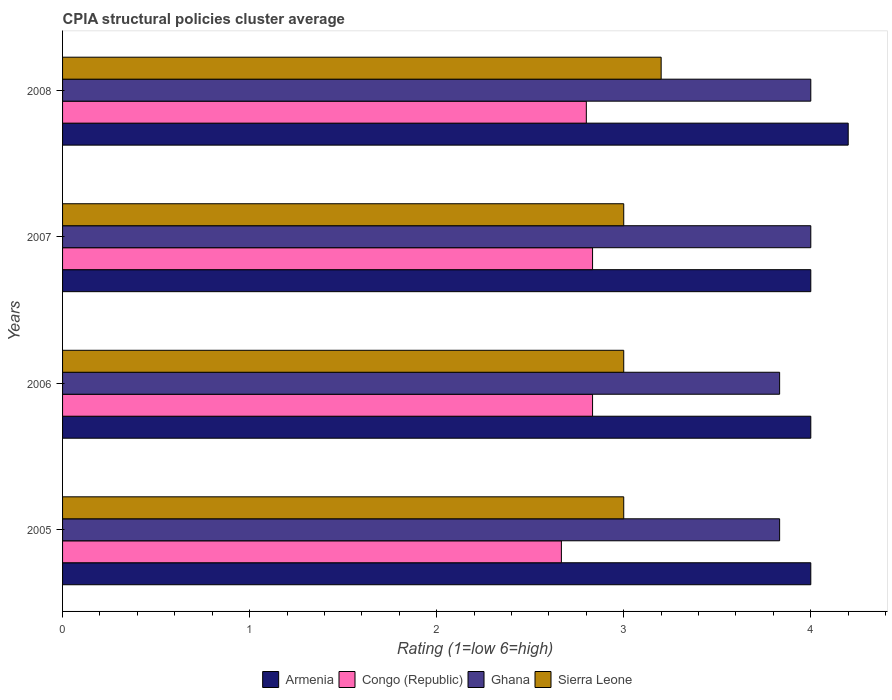How many different coloured bars are there?
Offer a very short reply. 4. How many groups of bars are there?
Offer a terse response. 4. What is the label of the 1st group of bars from the top?
Give a very brief answer. 2008. In how many cases, is the number of bars for a given year not equal to the number of legend labels?
Your response must be concise. 0. What is the CPIA rating in Ghana in 2006?
Provide a short and direct response. 3.83. Across all years, what is the maximum CPIA rating in Congo (Republic)?
Your response must be concise. 2.83. What is the difference between the CPIA rating in Congo (Republic) in 2006 and the CPIA rating in Armenia in 2005?
Ensure brevity in your answer.  -1.17. What is the average CPIA rating in Armenia per year?
Your response must be concise. 4.05. In the year 2005, what is the difference between the CPIA rating in Congo (Republic) and CPIA rating in Sierra Leone?
Offer a very short reply. -0.33. Is the CPIA rating in Armenia in 2006 less than that in 2008?
Make the answer very short. Yes. What is the difference between the highest and the second highest CPIA rating in Sierra Leone?
Offer a very short reply. 0.2. What is the difference between the highest and the lowest CPIA rating in Ghana?
Provide a short and direct response. 0.17. In how many years, is the CPIA rating in Ghana greater than the average CPIA rating in Ghana taken over all years?
Your response must be concise. 2. What does the 1st bar from the top in 2006 represents?
Your answer should be very brief. Sierra Leone. Is it the case that in every year, the sum of the CPIA rating in Armenia and CPIA rating in Ghana is greater than the CPIA rating in Sierra Leone?
Provide a succinct answer. Yes. How many years are there in the graph?
Keep it short and to the point. 4. Are the values on the major ticks of X-axis written in scientific E-notation?
Your response must be concise. No. Does the graph contain any zero values?
Offer a terse response. No. Does the graph contain grids?
Make the answer very short. No. How many legend labels are there?
Give a very brief answer. 4. What is the title of the graph?
Provide a short and direct response. CPIA structural policies cluster average. What is the label or title of the X-axis?
Make the answer very short. Rating (1=low 6=high). What is the Rating (1=low 6=high) of Armenia in 2005?
Keep it short and to the point. 4. What is the Rating (1=low 6=high) in Congo (Republic) in 2005?
Offer a very short reply. 2.67. What is the Rating (1=low 6=high) in Ghana in 2005?
Offer a terse response. 3.83. What is the Rating (1=low 6=high) of Sierra Leone in 2005?
Make the answer very short. 3. What is the Rating (1=low 6=high) of Congo (Republic) in 2006?
Your answer should be compact. 2.83. What is the Rating (1=low 6=high) in Ghana in 2006?
Offer a very short reply. 3.83. What is the Rating (1=low 6=high) in Armenia in 2007?
Keep it short and to the point. 4. What is the Rating (1=low 6=high) of Congo (Republic) in 2007?
Your response must be concise. 2.83. What is the Rating (1=low 6=high) of Congo (Republic) in 2008?
Keep it short and to the point. 2.8. What is the Rating (1=low 6=high) in Sierra Leone in 2008?
Your answer should be compact. 3.2. Across all years, what is the maximum Rating (1=low 6=high) of Congo (Republic)?
Provide a short and direct response. 2.83. Across all years, what is the minimum Rating (1=low 6=high) in Armenia?
Your response must be concise. 4. Across all years, what is the minimum Rating (1=low 6=high) in Congo (Republic)?
Offer a very short reply. 2.67. Across all years, what is the minimum Rating (1=low 6=high) in Ghana?
Make the answer very short. 3.83. What is the total Rating (1=low 6=high) of Armenia in the graph?
Give a very brief answer. 16.2. What is the total Rating (1=low 6=high) of Congo (Republic) in the graph?
Give a very brief answer. 11.13. What is the total Rating (1=low 6=high) of Ghana in the graph?
Offer a terse response. 15.67. What is the total Rating (1=low 6=high) of Sierra Leone in the graph?
Provide a succinct answer. 12.2. What is the difference between the Rating (1=low 6=high) in Congo (Republic) in 2005 and that in 2006?
Provide a short and direct response. -0.17. What is the difference between the Rating (1=low 6=high) of Ghana in 2005 and that in 2006?
Provide a short and direct response. 0. What is the difference between the Rating (1=low 6=high) in Sierra Leone in 2005 and that in 2007?
Give a very brief answer. 0. What is the difference between the Rating (1=low 6=high) of Armenia in 2005 and that in 2008?
Give a very brief answer. -0.2. What is the difference between the Rating (1=low 6=high) of Congo (Republic) in 2005 and that in 2008?
Your response must be concise. -0.13. What is the difference between the Rating (1=low 6=high) in Ghana in 2005 and that in 2008?
Provide a short and direct response. -0.17. What is the difference between the Rating (1=low 6=high) in Sierra Leone in 2005 and that in 2008?
Provide a succinct answer. -0.2. What is the difference between the Rating (1=low 6=high) in Congo (Republic) in 2006 and that in 2007?
Provide a succinct answer. 0. What is the difference between the Rating (1=low 6=high) in Armenia in 2006 and that in 2008?
Offer a terse response. -0.2. What is the difference between the Rating (1=low 6=high) in Congo (Republic) in 2007 and that in 2008?
Your answer should be compact. 0.03. What is the difference between the Rating (1=low 6=high) of Armenia in 2005 and the Rating (1=low 6=high) of Congo (Republic) in 2006?
Keep it short and to the point. 1.17. What is the difference between the Rating (1=low 6=high) in Armenia in 2005 and the Rating (1=low 6=high) in Ghana in 2006?
Offer a very short reply. 0.17. What is the difference between the Rating (1=low 6=high) of Congo (Republic) in 2005 and the Rating (1=low 6=high) of Ghana in 2006?
Offer a terse response. -1.17. What is the difference between the Rating (1=low 6=high) in Armenia in 2005 and the Rating (1=low 6=high) in Ghana in 2007?
Offer a terse response. 0. What is the difference between the Rating (1=low 6=high) in Armenia in 2005 and the Rating (1=low 6=high) in Sierra Leone in 2007?
Give a very brief answer. 1. What is the difference between the Rating (1=low 6=high) in Congo (Republic) in 2005 and the Rating (1=low 6=high) in Ghana in 2007?
Your response must be concise. -1.33. What is the difference between the Rating (1=low 6=high) in Congo (Republic) in 2005 and the Rating (1=low 6=high) in Ghana in 2008?
Keep it short and to the point. -1.33. What is the difference between the Rating (1=low 6=high) of Congo (Republic) in 2005 and the Rating (1=low 6=high) of Sierra Leone in 2008?
Your answer should be compact. -0.53. What is the difference between the Rating (1=low 6=high) in Ghana in 2005 and the Rating (1=low 6=high) in Sierra Leone in 2008?
Offer a terse response. 0.63. What is the difference between the Rating (1=low 6=high) of Armenia in 2006 and the Rating (1=low 6=high) of Sierra Leone in 2007?
Provide a short and direct response. 1. What is the difference between the Rating (1=low 6=high) in Congo (Republic) in 2006 and the Rating (1=low 6=high) in Ghana in 2007?
Your answer should be compact. -1.17. What is the difference between the Rating (1=low 6=high) in Congo (Republic) in 2006 and the Rating (1=low 6=high) in Sierra Leone in 2007?
Give a very brief answer. -0.17. What is the difference between the Rating (1=low 6=high) of Ghana in 2006 and the Rating (1=low 6=high) of Sierra Leone in 2007?
Offer a very short reply. 0.83. What is the difference between the Rating (1=low 6=high) of Armenia in 2006 and the Rating (1=low 6=high) of Congo (Republic) in 2008?
Keep it short and to the point. 1.2. What is the difference between the Rating (1=low 6=high) of Congo (Republic) in 2006 and the Rating (1=low 6=high) of Ghana in 2008?
Your answer should be compact. -1.17. What is the difference between the Rating (1=low 6=high) of Congo (Republic) in 2006 and the Rating (1=low 6=high) of Sierra Leone in 2008?
Ensure brevity in your answer.  -0.37. What is the difference between the Rating (1=low 6=high) in Ghana in 2006 and the Rating (1=low 6=high) in Sierra Leone in 2008?
Your answer should be very brief. 0.63. What is the difference between the Rating (1=low 6=high) of Armenia in 2007 and the Rating (1=low 6=high) of Congo (Republic) in 2008?
Your response must be concise. 1.2. What is the difference between the Rating (1=low 6=high) of Armenia in 2007 and the Rating (1=low 6=high) of Ghana in 2008?
Provide a short and direct response. 0. What is the difference between the Rating (1=low 6=high) of Congo (Republic) in 2007 and the Rating (1=low 6=high) of Ghana in 2008?
Keep it short and to the point. -1.17. What is the difference between the Rating (1=low 6=high) in Congo (Republic) in 2007 and the Rating (1=low 6=high) in Sierra Leone in 2008?
Ensure brevity in your answer.  -0.37. What is the average Rating (1=low 6=high) of Armenia per year?
Make the answer very short. 4.05. What is the average Rating (1=low 6=high) in Congo (Republic) per year?
Keep it short and to the point. 2.78. What is the average Rating (1=low 6=high) in Ghana per year?
Your answer should be very brief. 3.92. What is the average Rating (1=low 6=high) of Sierra Leone per year?
Ensure brevity in your answer.  3.05. In the year 2005, what is the difference between the Rating (1=low 6=high) in Armenia and Rating (1=low 6=high) in Sierra Leone?
Provide a short and direct response. 1. In the year 2005, what is the difference between the Rating (1=low 6=high) of Congo (Republic) and Rating (1=low 6=high) of Ghana?
Ensure brevity in your answer.  -1.17. In the year 2006, what is the difference between the Rating (1=low 6=high) in Armenia and Rating (1=low 6=high) in Congo (Republic)?
Keep it short and to the point. 1.17. In the year 2006, what is the difference between the Rating (1=low 6=high) in Armenia and Rating (1=low 6=high) in Ghana?
Offer a terse response. 0.17. In the year 2006, what is the difference between the Rating (1=low 6=high) in Congo (Republic) and Rating (1=low 6=high) in Ghana?
Your answer should be compact. -1. In the year 2007, what is the difference between the Rating (1=low 6=high) in Armenia and Rating (1=low 6=high) in Ghana?
Offer a terse response. 0. In the year 2007, what is the difference between the Rating (1=low 6=high) of Congo (Republic) and Rating (1=low 6=high) of Ghana?
Make the answer very short. -1.17. In the year 2007, what is the difference between the Rating (1=low 6=high) in Ghana and Rating (1=low 6=high) in Sierra Leone?
Provide a succinct answer. 1. In the year 2008, what is the difference between the Rating (1=low 6=high) of Armenia and Rating (1=low 6=high) of Congo (Republic)?
Your answer should be very brief. 1.4. In the year 2008, what is the difference between the Rating (1=low 6=high) in Armenia and Rating (1=low 6=high) in Sierra Leone?
Give a very brief answer. 1. In the year 2008, what is the difference between the Rating (1=low 6=high) in Ghana and Rating (1=low 6=high) in Sierra Leone?
Keep it short and to the point. 0.8. What is the ratio of the Rating (1=low 6=high) in Armenia in 2005 to that in 2006?
Provide a succinct answer. 1. What is the ratio of the Rating (1=low 6=high) of Congo (Republic) in 2005 to that in 2006?
Keep it short and to the point. 0.94. What is the ratio of the Rating (1=low 6=high) in Sierra Leone in 2005 to that in 2006?
Offer a very short reply. 1. What is the ratio of the Rating (1=low 6=high) of Armenia in 2005 to that in 2007?
Make the answer very short. 1. What is the ratio of the Rating (1=low 6=high) in Ghana in 2005 to that in 2007?
Your response must be concise. 0.96. What is the ratio of the Rating (1=low 6=high) of Sierra Leone in 2005 to that in 2007?
Keep it short and to the point. 1. What is the ratio of the Rating (1=low 6=high) of Congo (Republic) in 2005 to that in 2008?
Provide a short and direct response. 0.95. What is the ratio of the Rating (1=low 6=high) of Ghana in 2005 to that in 2008?
Your answer should be compact. 0.96. What is the ratio of the Rating (1=low 6=high) in Ghana in 2006 to that in 2007?
Offer a very short reply. 0.96. What is the ratio of the Rating (1=low 6=high) of Armenia in 2006 to that in 2008?
Provide a short and direct response. 0.95. What is the ratio of the Rating (1=low 6=high) in Congo (Republic) in 2006 to that in 2008?
Keep it short and to the point. 1.01. What is the ratio of the Rating (1=low 6=high) of Ghana in 2006 to that in 2008?
Your answer should be very brief. 0.96. What is the ratio of the Rating (1=low 6=high) of Armenia in 2007 to that in 2008?
Provide a short and direct response. 0.95. What is the ratio of the Rating (1=low 6=high) in Congo (Republic) in 2007 to that in 2008?
Your answer should be compact. 1.01. What is the ratio of the Rating (1=low 6=high) of Ghana in 2007 to that in 2008?
Keep it short and to the point. 1. What is the ratio of the Rating (1=low 6=high) in Sierra Leone in 2007 to that in 2008?
Provide a succinct answer. 0.94. What is the difference between the highest and the second highest Rating (1=low 6=high) of Congo (Republic)?
Provide a short and direct response. 0. What is the difference between the highest and the second highest Rating (1=low 6=high) in Ghana?
Make the answer very short. 0. What is the difference between the highest and the lowest Rating (1=low 6=high) in Armenia?
Provide a short and direct response. 0.2. What is the difference between the highest and the lowest Rating (1=low 6=high) of Sierra Leone?
Ensure brevity in your answer.  0.2. 